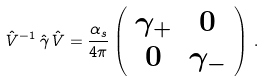<formula> <loc_0><loc_0><loc_500><loc_500>\hat { V } ^ { - 1 } \, \hat { \gamma } \, \hat { V } = \frac { \alpha _ { s } } { 4 \pi } \left ( \begin{array} { c c } \gamma _ { + } & 0 \\ 0 & \gamma _ { - } \\ \end{array} \right ) \, .</formula> 